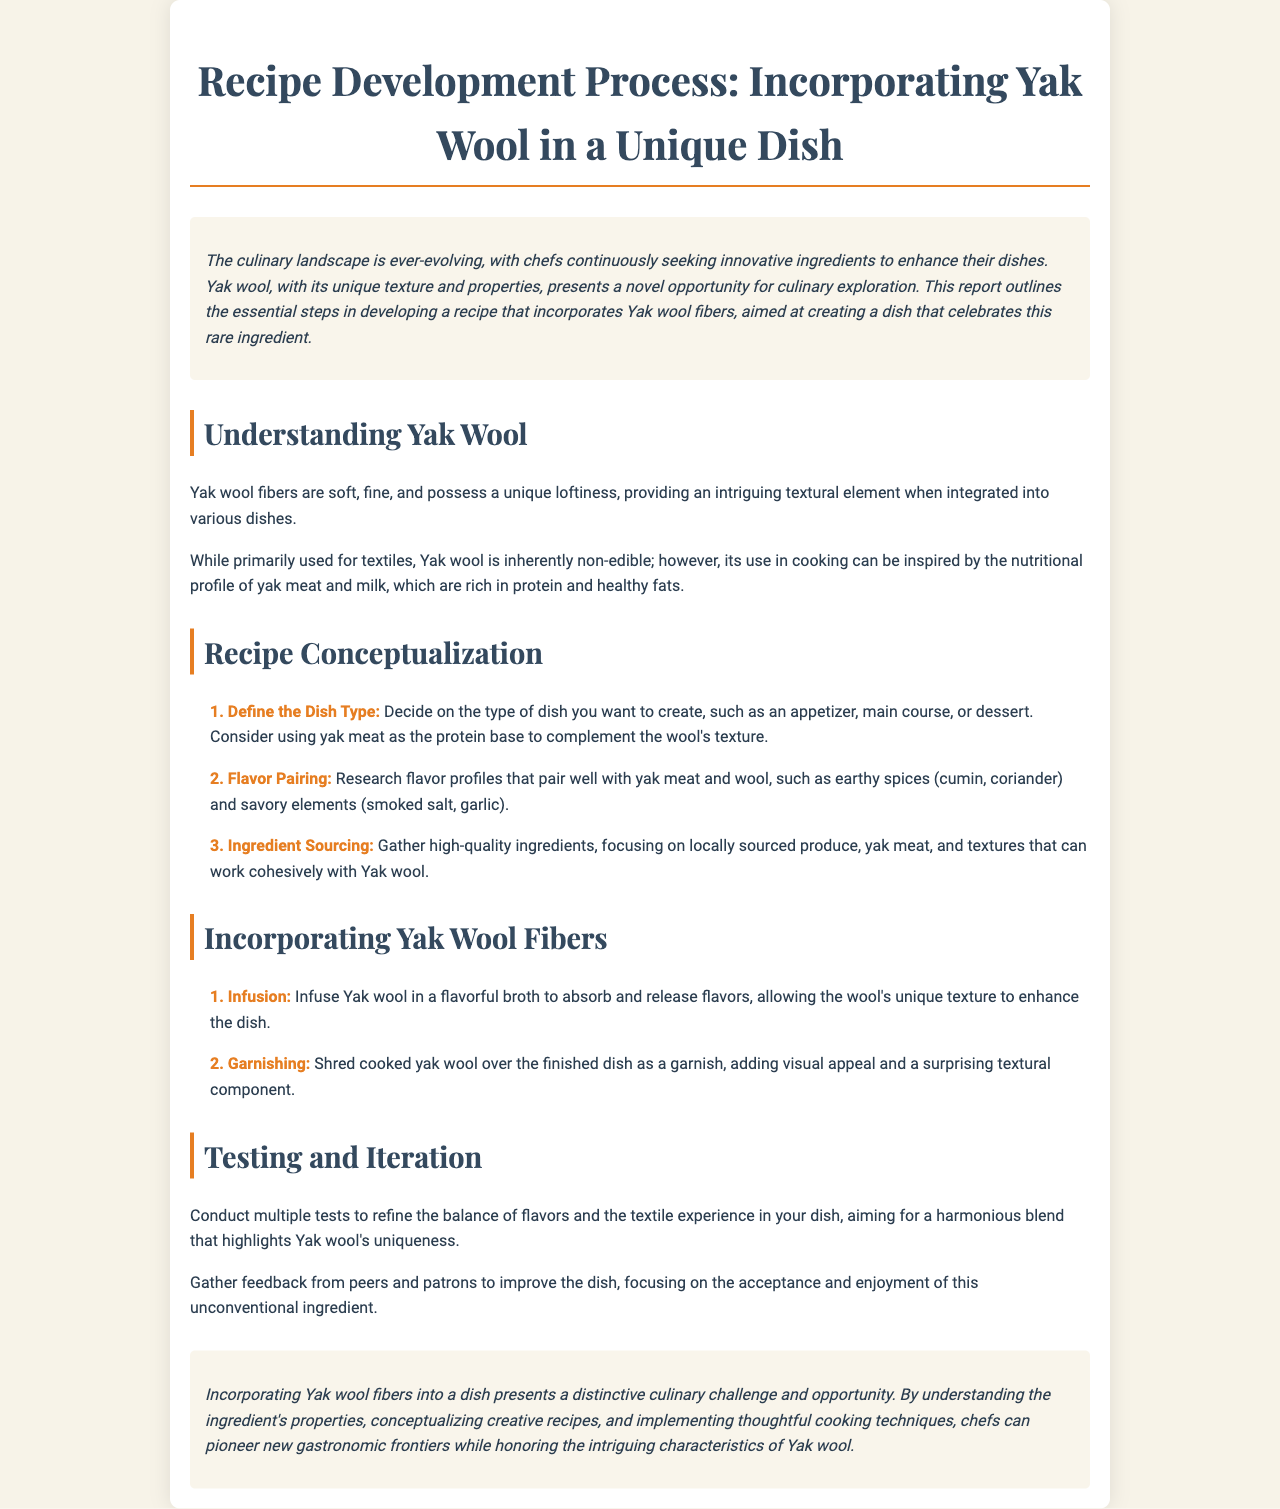what is the title of the report? The title of the report is mentioned at the beginning, encapsulating the main focus of the document.
Answer: Recipe Development Process: Incorporating Yak Wool in a Unique Dish what is the unique quality of Yak wool mentioned? The report describes Yak wool as having a specific texture that enhances dishes, which is highlighted in the introduction.
Answer: Unique loftiness what is the first step in recipe conceptualization? The first step involves defining what type of dish is to be created, which is outlined in the steps section.
Answer: Define the Dish Type which spices are suggested for flavor pairing? The report lists specific spices that would complement yak meat and wool, found in the flavor pairing step.
Answer: Cumin, coriander what method is suggested for infusing Yak wool? The document specifies a method for integrating the unique texture of Yak wool into a dish, found in the methods section.
Answer: Infusion how many steps are there in the recipe conceptualization section? By counting the steps mentioned, you can determine the number present in the recipe conceptualization section.
Answer: Three what is the main focus of testing and iteration? This section emphasizes the purpose behind testing the dish, detailing the gathering of feedback for improvement.
Answer: Refine the balance of flavors what type of feedback is emphasized for improvement? The document suggests an aspect of feedback essential for refining the dish, mentioned in the testing and iteration section.
Answer: Acceptance and enjoyment how is Yak wool used as a garnish? The report describes a specific way to present Yak wool in a dish that enhances visual appeal, found in the methods section.
Answer: Shred cooked yak wool over the finished dish 